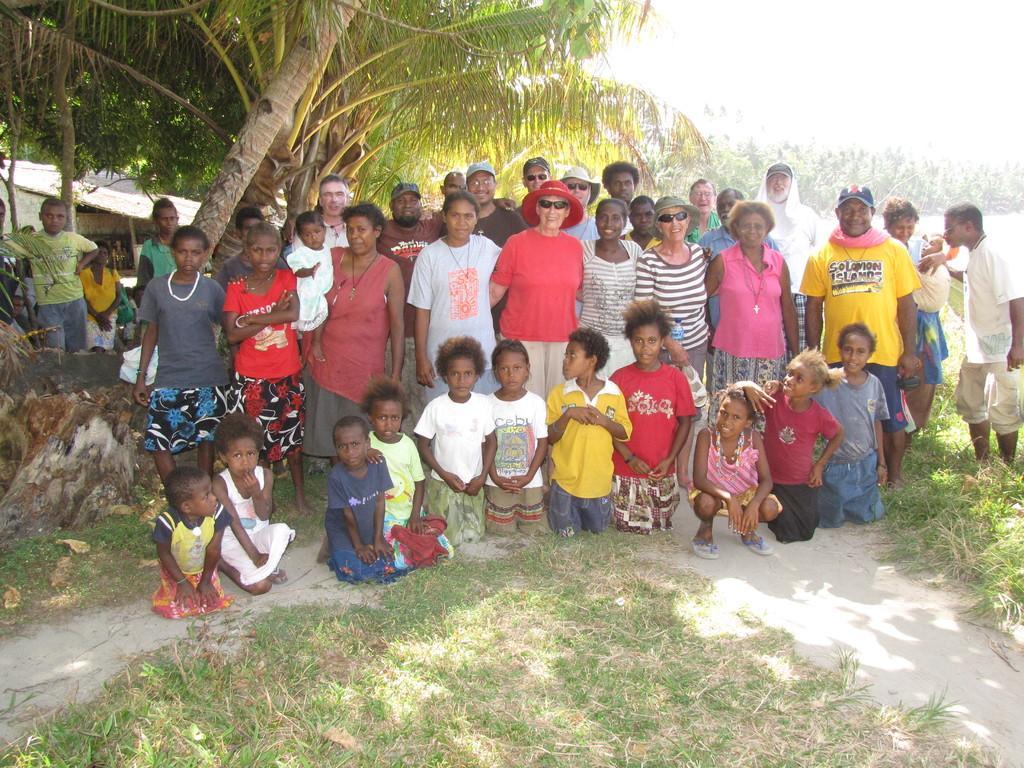Could you give a brief overview of what you see in this image? There are group of people on the ground. Here we can see grass, hut, and trees. 